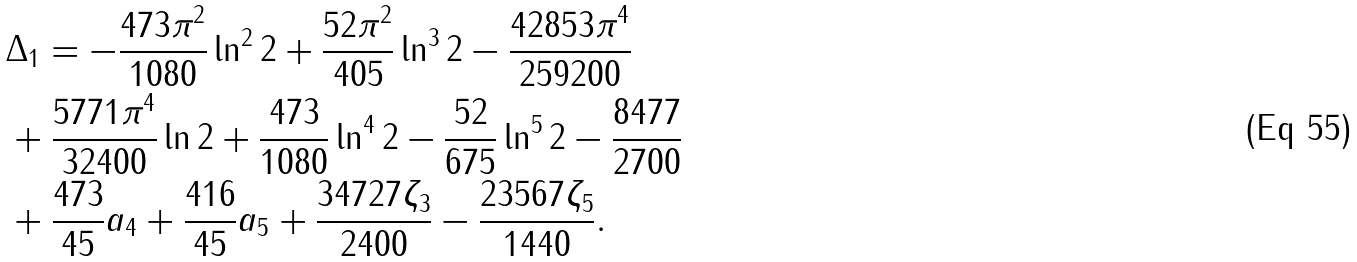Convert formula to latex. <formula><loc_0><loc_0><loc_500><loc_500>& \Delta _ { 1 } = - \frac { 4 7 3 \pi ^ { 2 } } { 1 0 8 0 } \ln ^ { 2 } 2 + \frac { 5 2 \pi ^ { 2 } } { 4 0 5 } \ln ^ { 3 } 2 - \frac { 4 2 8 5 3 \pi ^ { 4 } } { 2 5 9 2 0 0 } \\ & + \frac { 5 7 7 1 \pi ^ { 4 } } { 3 2 4 0 0 } \ln 2 + \frac { 4 7 3 } { 1 0 8 0 } \ln ^ { 4 } 2 - \frac { 5 2 } { 6 7 5 } \ln ^ { 5 } 2 - \frac { 8 4 7 7 } { 2 7 0 0 } \\ & + \frac { 4 7 3 } { 4 5 } a _ { 4 } + \frac { 4 1 6 } { 4 5 } a _ { 5 } + \frac { 3 4 7 2 7 \zeta _ { 3 } } { 2 4 0 0 } - \frac { 2 3 5 6 7 \zeta _ { 5 } } { 1 4 4 0 } .</formula> 